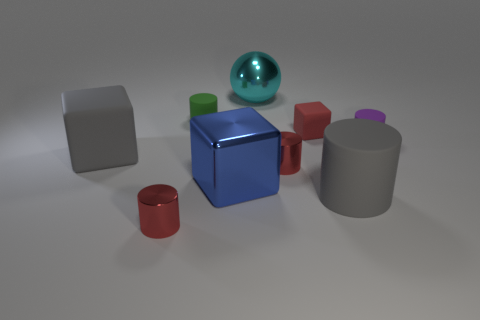How many other matte things have the same size as the cyan object?
Keep it short and to the point. 2. There is a big matte thing that is the same color as the big rubber cylinder; what shape is it?
Offer a very short reply. Cube. Do the cube on the right side of the cyan ball and the tiny metal thing that is to the right of the green rubber cylinder have the same color?
Your answer should be compact. Yes. How many tiny red shiny cylinders are on the right side of the cyan object?
Provide a short and direct response. 1. What size is the matte object that is the same color as the big matte block?
Offer a very short reply. Large. Is there a blue thing that has the same shape as the green rubber thing?
Provide a short and direct response. No. What color is the block that is the same size as the blue shiny object?
Give a very brief answer. Gray. Is the number of shiny cylinders that are behind the purple rubber thing less than the number of big metal things behind the big gray matte cube?
Offer a terse response. Yes. Is the size of the gray matte object that is in front of the gray block the same as the purple matte cylinder?
Your response must be concise. No. There is a big thing that is behind the tiny purple matte thing; what shape is it?
Provide a short and direct response. Sphere. 